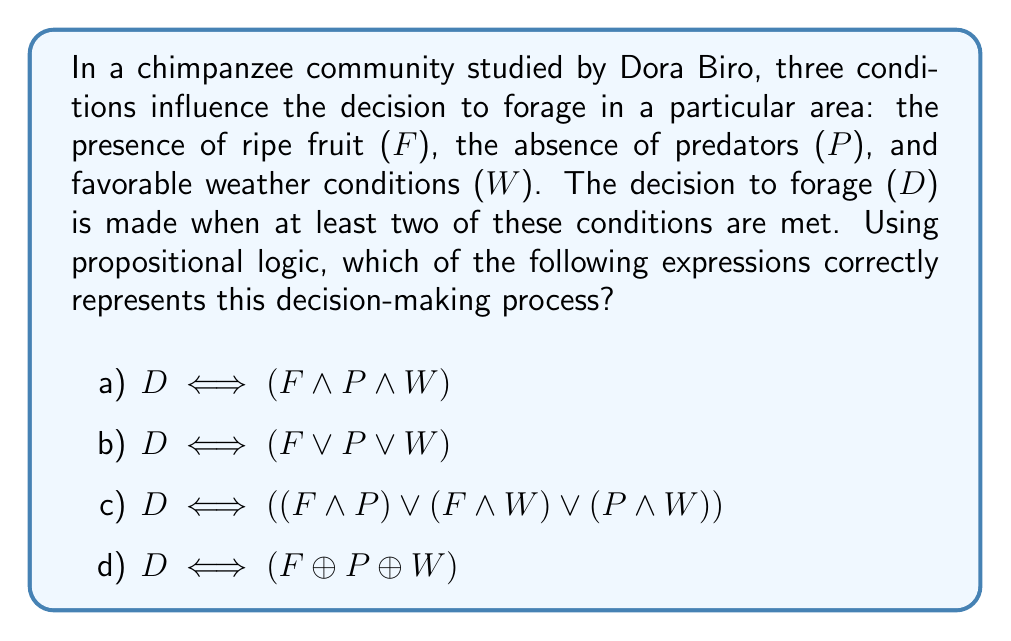Give your solution to this math problem. Let's break down the problem and analyze each option using propositional logic:

1) First, we need to understand the decision rule: foraging occurs when at least two of the three conditions (F, P, W) are met.

2) Let's examine each option:

   a) $D \iff (F \land P \land W)$
      This expression means foraging occurs if and only if all three conditions are met. This is too restrictive and doesn't match the given rule.

   b) $D \iff (F \lor P \lor W)$
      This expression means foraging occurs if at least one condition is met. This is too permissive and doesn't match the given rule.

   c) $D \iff ((F \land P) \lor (F \land W) \lor (P \land W))$
      This expression means foraging occurs if and only if at least two conditions are met. This matches the given rule.

   d) $D \iff (F \oplus P \oplus W)$
      The exclusive OR ($\oplus$) is true when an odd number of its operands are true. This would be true when exactly one or all three conditions are met, which doesn't match the given rule.

3) We can verify option c by creating a truth table:

   $$
   \begin{array}{|c|c|c|c|c|}
   \hline
   F & P & W & (F \land P) \lor (F \land W) \lor (P \land W) & D \\
   \hline
   0 & 0 & 0 & 0 & 0 \\
   0 & 0 & 1 & 0 & 0 \\
   0 & 1 & 0 & 0 & 0 \\
   0 & 1 & 1 & 1 & 1 \\
   1 & 0 & 0 & 0 & 0 \\
   1 & 0 & 1 & 1 & 1 \\
   1 & 1 & 0 & 1 & 1 \\
   1 & 1 & 1 & 1 & 1 \\
   \hline
   \end{array}
   $$

   The truth table confirms that option c correctly represents the decision-making process.
Answer: c) $D \iff ((F \land P) \lor (F \land W) \lor (P \land W))$ 